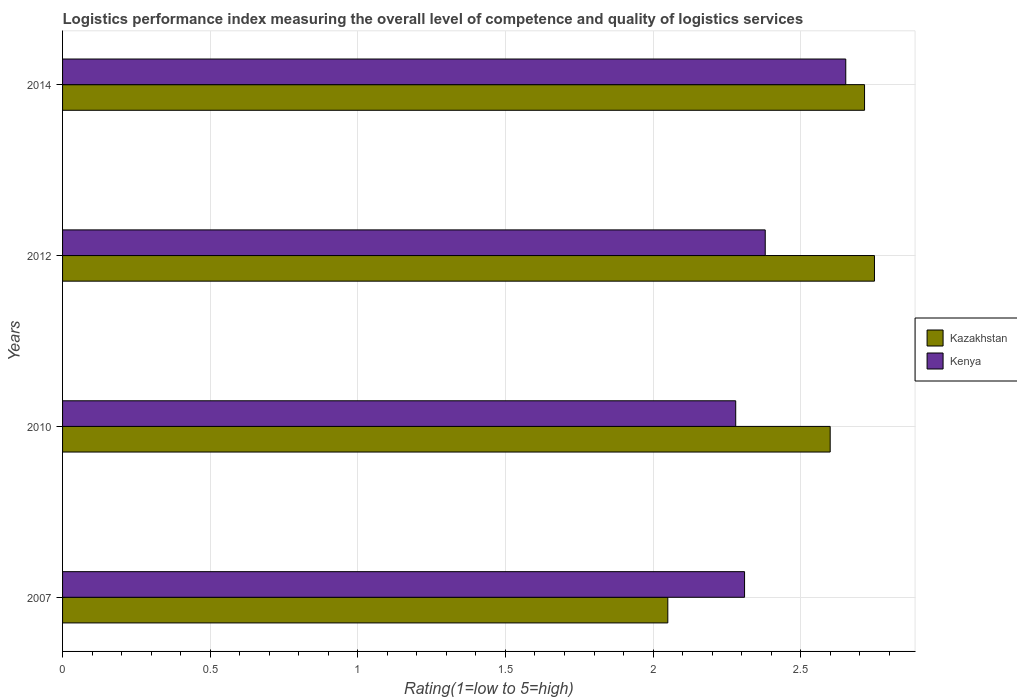How many different coloured bars are there?
Your response must be concise. 2. How many groups of bars are there?
Provide a succinct answer. 4. Are the number of bars per tick equal to the number of legend labels?
Offer a terse response. Yes. What is the Logistic performance index in Kenya in 2010?
Your answer should be compact. 2.28. Across all years, what is the maximum Logistic performance index in Kenya?
Your answer should be very brief. 2.65. Across all years, what is the minimum Logistic performance index in Kazakhstan?
Your answer should be compact. 2.05. In which year was the Logistic performance index in Kenya maximum?
Your response must be concise. 2014. In which year was the Logistic performance index in Kenya minimum?
Ensure brevity in your answer.  2010. What is the total Logistic performance index in Kazakhstan in the graph?
Provide a succinct answer. 10.12. What is the difference between the Logistic performance index in Kazakhstan in 2012 and that in 2014?
Provide a succinct answer. 0.03. What is the difference between the Logistic performance index in Kazakhstan in 2014 and the Logistic performance index in Kenya in 2007?
Your response must be concise. 0.41. What is the average Logistic performance index in Kazakhstan per year?
Make the answer very short. 2.53. In the year 2010, what is the difference between the Logistic performance index in Kazakhstan and Logistic performance index in Kenya?
Provide a short and direct response. 0.32. What is the ratio of the Logistic performance index in Kazakhstan in 2007 to that in 2010?
Your response must be concise. 0.79. What is the difference between the highest and the second highest Logistic performance index in Kenya?
Keep it short and to the point. 0.27. What is the difference between the highest and the lowest Logistic performance index in Kenya?
Give a very brief answer. 0.37. What does the 2nd bar from the top in 2012 represents?
Your answer should be very brief. Kazakhstan. What does the 1st bar from the bottom in 2014 represents?
Your answer should be compact. Kazakhstan. Are all the bars in the graph horizontal?
Make the answer very short. Yes. How many years are there in the graph?
Give a very brief answer. 4. What is the difference between two consecutive major ticks on the X-axis?
Your answer should be very brief. 0.5. Are the values on the major ticks of X-axis written in scientific E-notation?
Offer a terse response. No. Does the graph contain any zero values?
Make the answer very short. No. How many legend labels are there?
Offer a very short reply. 2. What is the title of the graph?
Make the answer very short. Logistics performance index measuring the overall level of competence and quality of logistics services. What is the label or title of the X-axis?
Keep it short and to the point. Rating(1=low to 5=high). What is the Rating(1=low to 5=high) in Kazakhstan in 2007?
Keep it short and to the point. 2.05. What is the Rating(1=low to 5=high) in Kenya in 2007?
Give a very brief answer. 2.31. What is the Rating(1=low to 5=high) of Kazakhstan in 2010?
Provide a short and direct response. 2.6. What is the Rating(1=low to 5=high) of Kenya in 2010?
Offer a terse response. 2.28. What is the Rating(1=low to 5=high) in Kazakhstan in 2012?
Offer a very short reply. 2.75. What is the Rating(1=low to 5=high) in Kenya in 2012?
Your answer should be very brief. 2.38. What is the Rating(1=low to 5=high) of Kazakhstan in 2014?
Make the answer very short. 2.72. What is the Rating(1=low to 5=high) of Kenya in 2014?
Offer a very short reply. 2.65. Across all years, what is the maximum Rating(1=low to 5=high) in Kazakhstan?
Your answer should be compact. 2.75. Across all years, what is the maximum Rating(1=low to 5=high) of Kenya?
Give a very brief answer. 2.65. Across all years, what is the minimum Rating(1=low to 5=high) of Kazakhstan?
Make the answer very short. 2.05. Across all years, what is the minimum Rating(1=low to 5=high) in Kenya?
Your answer should be very brief. 2.28. What is the total Rating(1=low to 5=high) in Kazakhstan in the graph?
Ensure brevity in your answer.  10.12. What is the total Rating(1=low to 5=high) of Kenya in the graph?
Your answer should be compact. 9.62. What is the difference between the Rating(1=low to 5=high) in Kazakhstan in 2007 and that in 2010?
Provide a short and direct response. -0.55. What is the difference between the Rating(1=low to 5=high) of Kenya in 2007 and that in 2012?
Offer a terse response. -0.07. What is the difference between the Rating(1=low to 5=high) in Kazakhstan in 2007 and that in 2014?
Keep it short and to the point. -0.67. What is the difference between the Rating(1=low to 5=high) in Kenya in 2007 and that in 2014?
Offer a terse response. -0.34. What is the difference between the Rating(1=low to 5=high) of Kenya in 2010 and that in 2012?
Provide a succinct answer. -0.1. What is the difference between the Rating(1=low to 5=high) of Kazakhstan in 2010 and that in 2014?
Provide a short and direct response. -0.12. What is the difference between the Rating(1=low to 5=high) in Kenya in 2010 and that in 2014?
Your answer should be compact. -0.37. What is the difference between the Rating(1=low to 5=high) of Kazakhstan in 2012 and that in 2014?
Make the answer very short. 0.03. What is the difference between the Rating(1=low to 5=high) of Kenya in 2012 and that in 2014?
Offer a very short reply. -0.27. What is the difference between the Rating(1=low to 5=high) of Kazakhstan in 2007 and the Rating(1=low to 5=high) of Kenya in 2010?
Offer a very short reply. -0.23. What is the difference between the Rating(1=low to 5=high) in Kazakhstan in 2007 and the Rating(1=low to 5=high) in Kenya in 2012?
Offer a terse response. -0.33. What is the difference between the Rating(1=low to 5=high) in Kazakhstan in 2007 and the Rating(1=low to 5=high) in Kenya in 2014?
Your answer should be compact. -0.6. What is the difference between the Rating(1=low to 5=high) in Kazakhstan in 2010 and the Rating(1=low to 5=high) in Kenya in 2012?
Ensure brevity in your answer.  0.22. What is the difference between the Rating(1=low to 5=high) of Kazakhstan in 2010 and the Rating(1=low to 5=high) of Kenya in 2014?
Your answer should be very brief. -0.05. What is the difference between the Rating(1=low to 5=high) of Kazakhstan in 2012 and the Rating(1=low to 5=high) of Kenya in 2014?
Give a very brief answer. 0.1. What is the average Rating(1=low to 5=high) of Kazakhstan per year?
Make the answer very short. 2.53. What is the average Rating(1=low to 5=high) of Kenya per year?
Your answer should be compact. 2.41. In the year 2007, what is the difference between the Rating(1=low to 5=high) of Kazakhstan and Rating(1=low to 5=high) of Kenya?
Your answer should be compact. -0.26. In the year 2010, what is the difference between the Rating(1=low to 5=high) of Kazakhstan and Rating(1=low to 5=high) of Kenya?
Ensure brevity in your answer.  0.32. In the year 2012, what is the difference between the Rating(1=low to 5=high) of Kazakhstan and Rating(1=low to 5=high) of Kenya?
Offer a very short reply. 0.37. In the year 2014, what is the difference between the Rating(1=low to 5=high) of Kazakhstan and Rating(1=low to 5=high) of Kenya?
Offer a very short reply. 0.06. What is the ratio of the Rating(1=low to 5=high) in Kazakhstan in 2007 to that in 2010?
Provide a succinct answer. 0.79. What is the ratio of the Rating(1=low to 5=high) in Kenya in 2007 to that in 2010?
Ensure brevity in your answer.  1.01. What is the ratio of the Rating(1=low to 5=high) in Kazakhstan in 2007 to that in 2012?
Your answer should be compact. 0.75. What is the ratio of the Rating(1=low to 5=high) of Kenya in 2007 to that in 2012?
Offer a very short reply. 0.97. What is the ratio of the Rating(1=low to 5=high) of Kazakhstan in 2007 to that in 2014?
Provide a succinct answer. 0.75. What is the ratio of the Rating(1=low to 5=high) in Kenya in 2007 to that in 2014?
Provide a succinct answer. 0.87. What is the ratio of the Rating(1=low to 5=high) of Kazakhstan in 2010 to that in 2012?
Your response must be concise. 0.95. What is the ratio of the Rating(1=low to 5=high) in Kenya in 2010 to that in 2012?
Offer a very short reply. 0.96. What is the ratio of the Rating(1=low to 5=high) in Kazakhstan in 2010 to that in 2014?
Make the answer very short. 0.96. What is the ratio of the Rating(1=low to 5=high) in Kenya in 2010 to that in 2014?
Provide a succinct answer. 0.86. What is the ratio of the Rating(1=low to 5=high) in Kazakhstan in 2012 to that in 2014?
Offer a terse response. 1.01. What is the ratio of the Rating(1=low to 5=high) in Kenya in 2012 to that in 2014?
Your response must be concise. 0.9. What is the difference between the highest and the second highest Rating(1=low to 5=high) of Kazakhstan?
Your response must be concise. 0.03. What is the difference between the highest and the second highest Rating(1=low to 5=high) of Kenya?
Your answer should be very brief. 0.27. What is the difference between the highest and the lowest Rating(1=low to 5=high) in Kenya?
Ensure brevity in your answer.  0.37. 